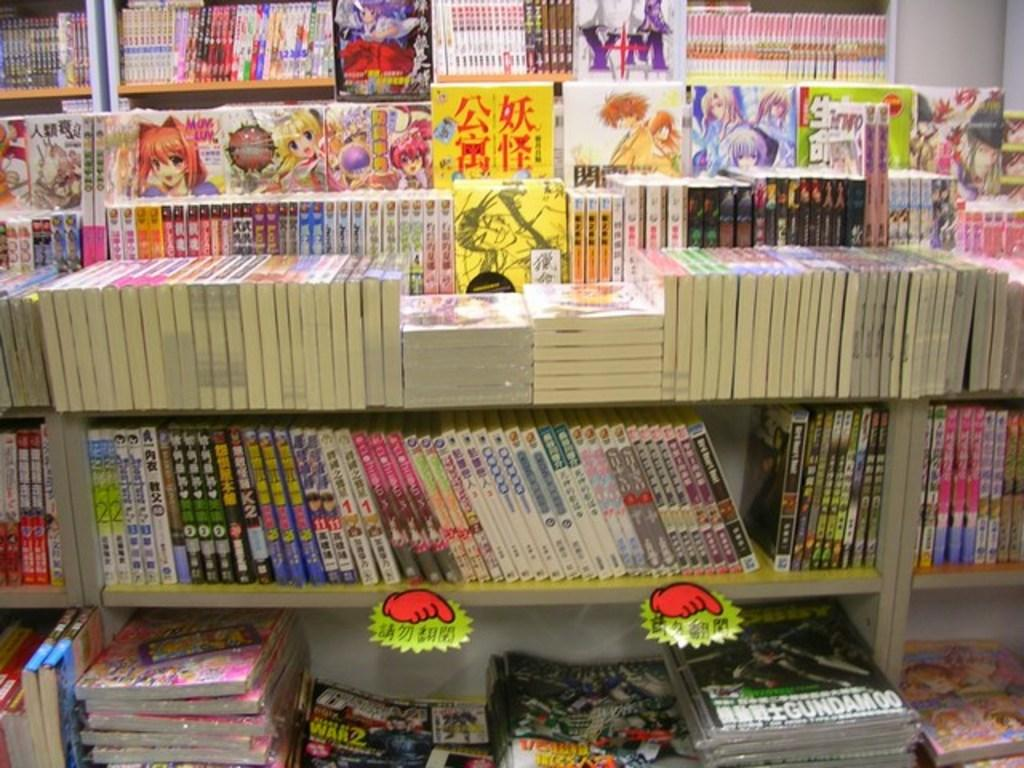<image>
Write a terse but informative summary of the picture. Mangas and magazines are for sale displayed on shelves and the bottom right magazine has Gundam on it. 